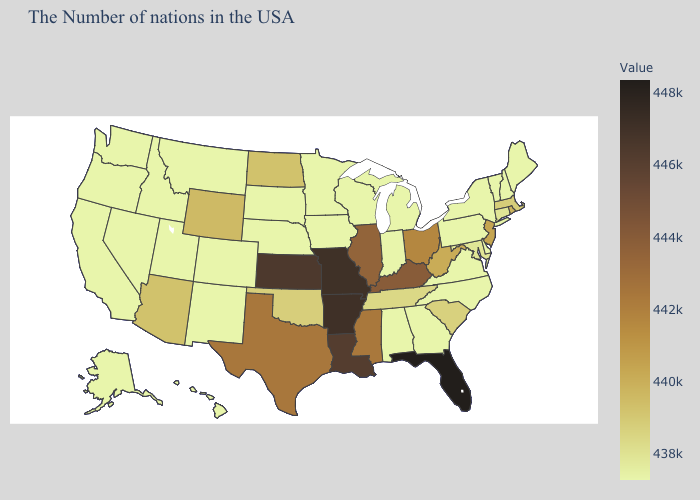Among the states that border Montana , does North Dakota have the lowest value?
Keep it brief. No. 